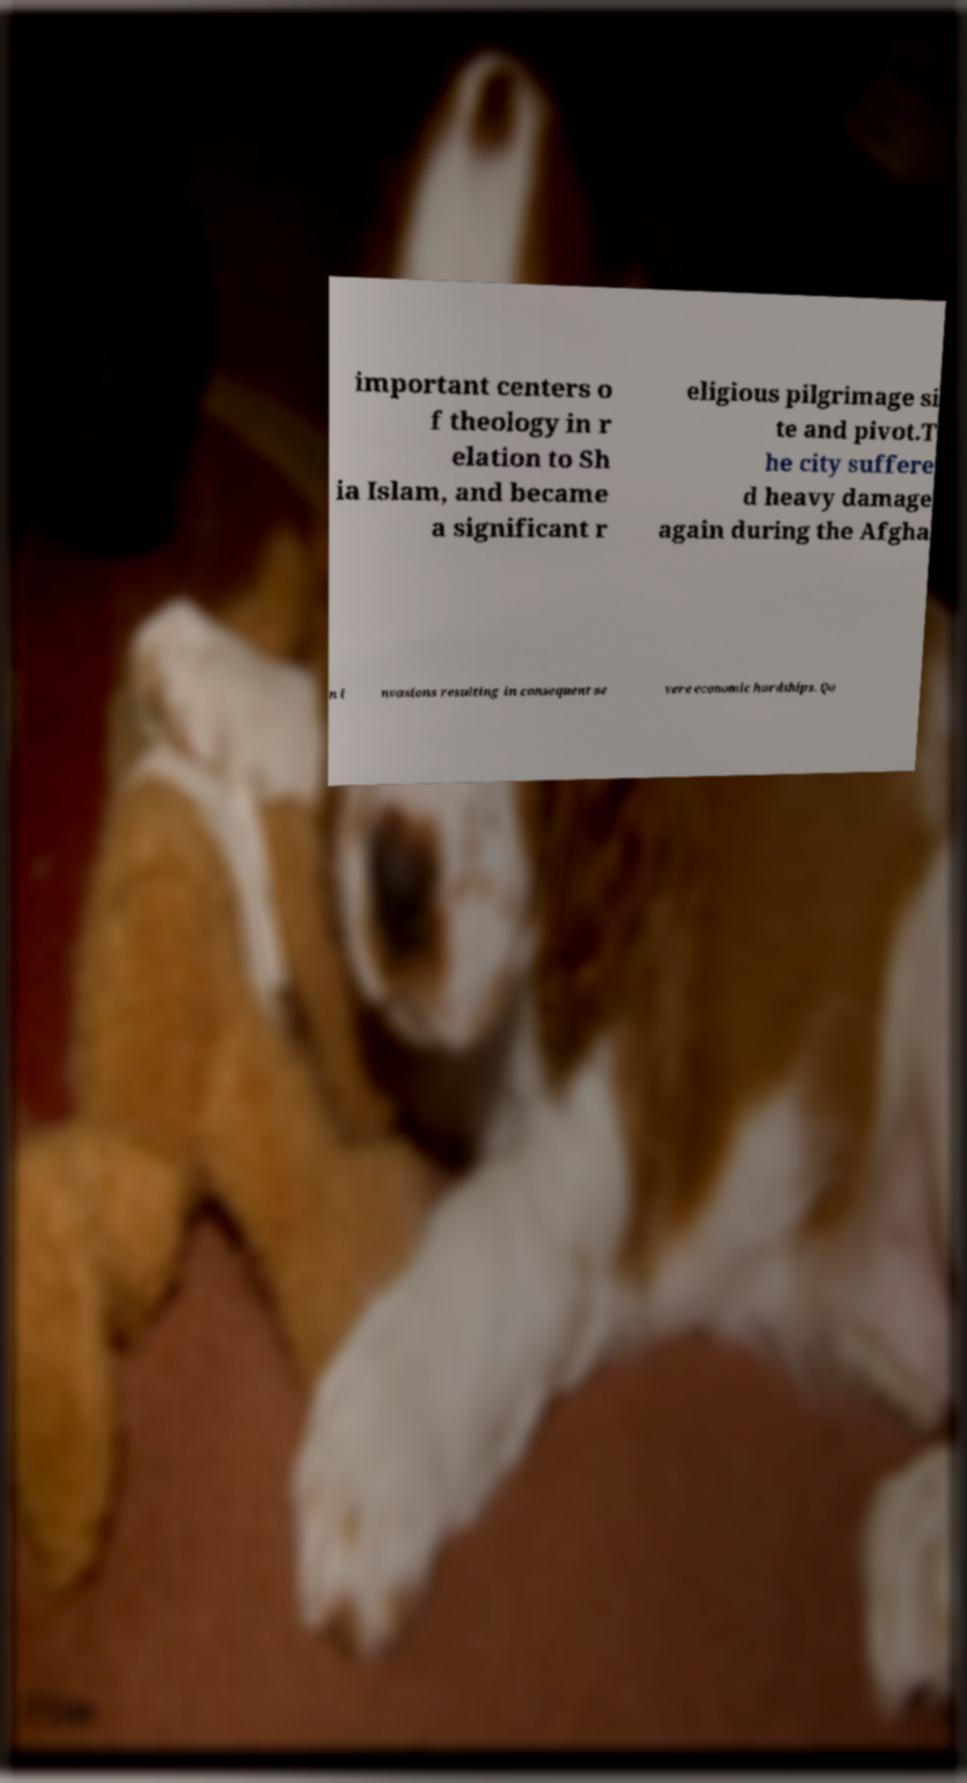What messages or text are displayed in this image? I need them in a readable, typed format. important centers o f theology in r elation to Sh ia Islam, and became a significant r eligious pilgrimage si te and pivot.T he city suffere d heavy damage again during the Afgha n i nvasions resulting in consequent se vere economic hardships. Qo 